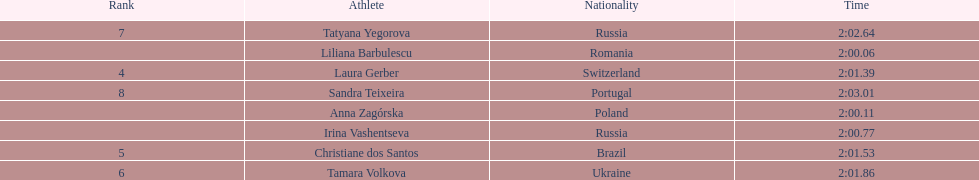What is the name of the top finalist of this semifinals heat? Liliana Barbulescu. 